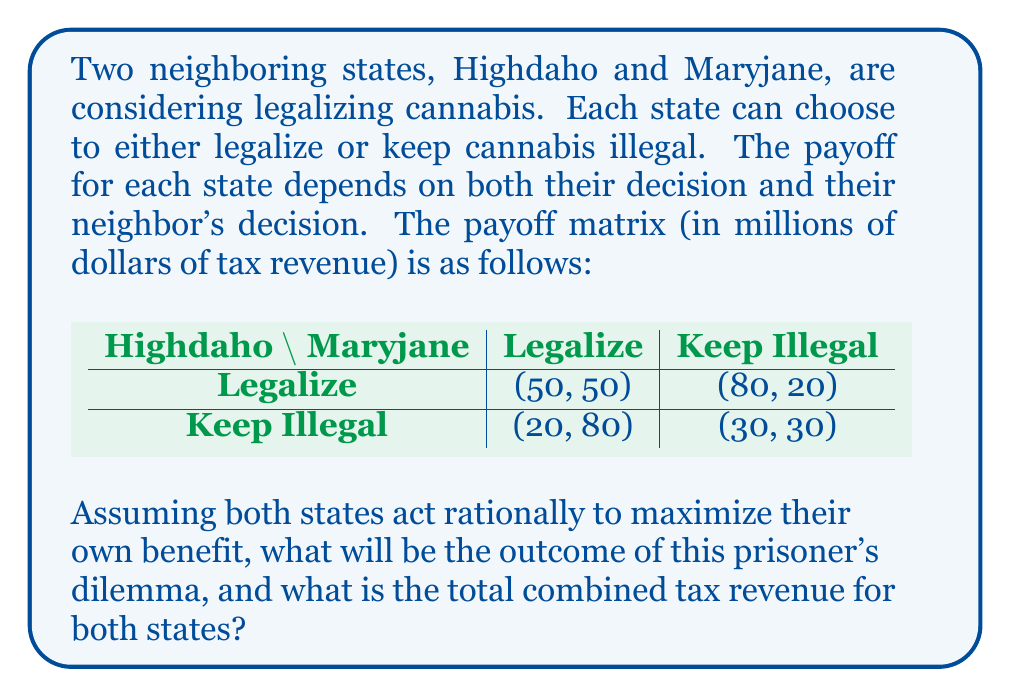Can you answer this question? To analyze this prisoner's dilemma, we need to consider the best strategy for each state, given the possible actions of the other state.

For Highdaho:
1. If Maryjane legalizes, Highdaho's best option is to legalize (50 > 20)
2. If Maryjane keeps illegal, Highdaho's best option is to legalize (80 > 30)

For Maryjane:
1. If Highdaho legalizes, Maryjane's best option is to legalize (50 > 20)
2. If Highdaho keeps illegal, Maryjane's best option is to legalize (80 > 30)

In this case, legalizing is the dominant strategy for both states, regardless of what the other state does. This leads to a Nash equilibrium where both states choose to legalize cannabis.

The outcome of the prisoner's dilemma is (Legalize, Legalize), resulting in a payoff of (50, 50) million dollars in tax revenue for each state.

The total combined tax revenue is calculated as:

$$ \text{Total Revenue} = 50 + 50 = 100 \text{ million dollars} $$

It's worth noting that while this is not the highest possible combined payoff (which would be 100 million if one state legalized and the other didn't), it is the most stable outcome given the incentives for each state.
Answer: The outcome of the prisoner's dilemma is that both states will legalize cannabis, and the total combined tax revenue for both states will be $100 million. 